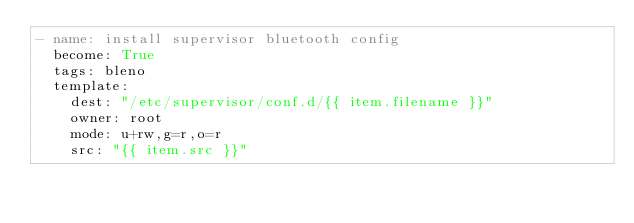Convert code to text. <code><loc_0><loc_0><loc_500><loc_500><_YAML_>- name: install supervisor bluetooth config
  become: True
  tags: bleno
  template:
    dest: "/etc/supervisor/conf.d/{{ item.filename }}"
    owner: root
    mode: u+rw,g=r,o=r
    src: "{{ item.src }}"</code> 